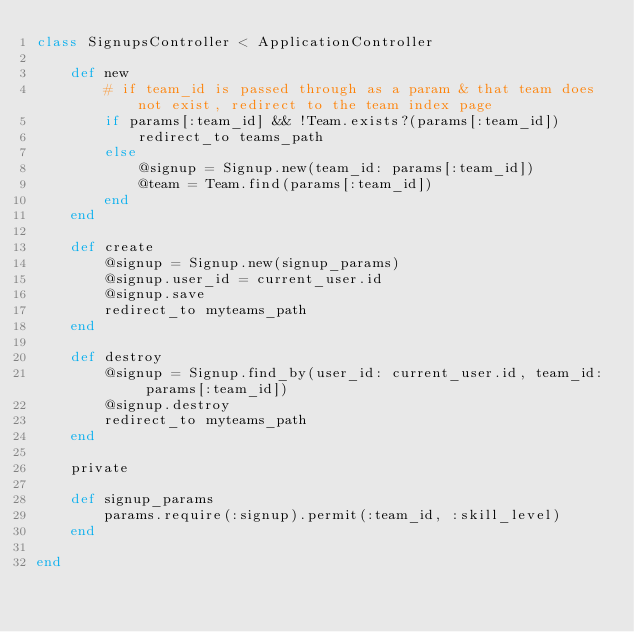Convert code to text. <code><loc_0><loc_0><loc_500><loc_500><_Ruby_>class SignupsController < ApplicationController

    def new
        # if team_id is passed through as a param & that team does not exist, redirect to the team index page
        if params[:team_id] && !Team.exists?(params[:team_id])
            redirect_to teams_path
        else
            @signup = Signup.new(team_id: params[:team_id])
            @team = Team.find(params[:team_id])
        end
    end

    def create
        @signup = Signup.new(signup_params)
        @signup.user_id = current_user.id
        @signup.save
        redirect_to myteams_path
    end

    def destroy
        @signup = Signup.find_by(user_id: current_user.id, team_id: params[:team_id])
        @signup.destroy
        redirect_to myteams_path
    end

    private

    def signup_params
        params.require(:signup).permit(:team_id, :skill_level)
    end

end
</code> 